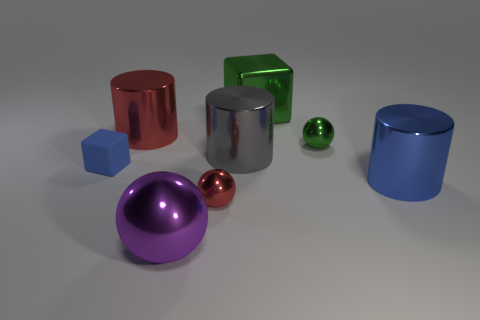Is there anything else that is the same color as the big ball?
Offer a very short reply. No. Do the large blue thing and the purple metal thing have the same shape?
Ensure brevity in your answer.  No. Are there fewer green objects than small green metallic balls?
Provide a succinct answer. No. How many small things are either blue rubber cubes or green objects?
Offer a very short reply. 2. How many objects are both in front of the big red shiny object and left of the large metallic ball?
Offer a very short reply. 1. Are there more small green things than cyan matte cubes?
Offer a terse response. Yes. How many other things are the same shape as the large blue thing?
Your response must be concise. 2. Do the matte cube and the large block have the same color?
Your response must be concise. No. There is a large thing that is behind the big gray thing and left of the big green block; what is its material?
Your answer should be very brief. Metal. The gray metallic cylinder has what size?
Make the answer very short. Large. 